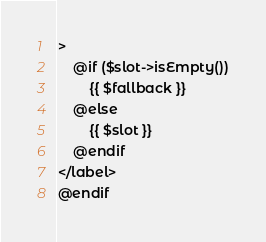<code> <loc_0><loc_0><loc_500><loc_500><_PHP_>>
    @if ($slot->isEmpty())
        {{ $fallback }}
    @else
        {{ $slot }}
    @endif
</label>
@endif
</code> 